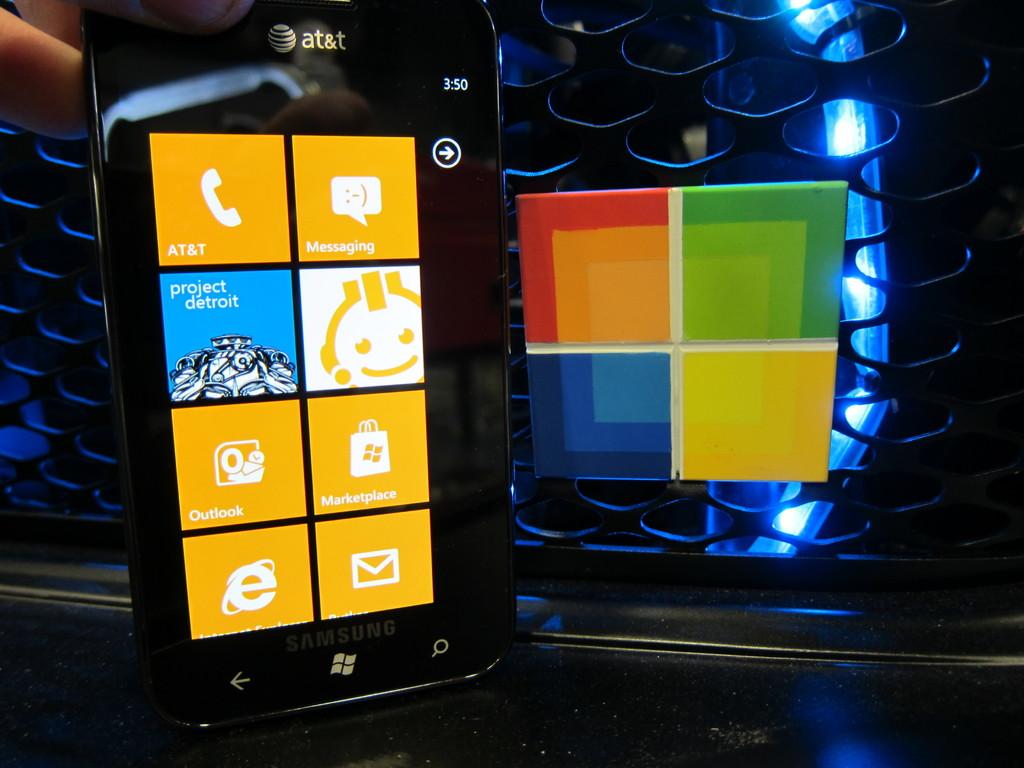What is the phone provider?
Provide a short and direct response. At&t. What city does the phone mention below at&t?
Ensure brevity in your answer.  Detroit. 